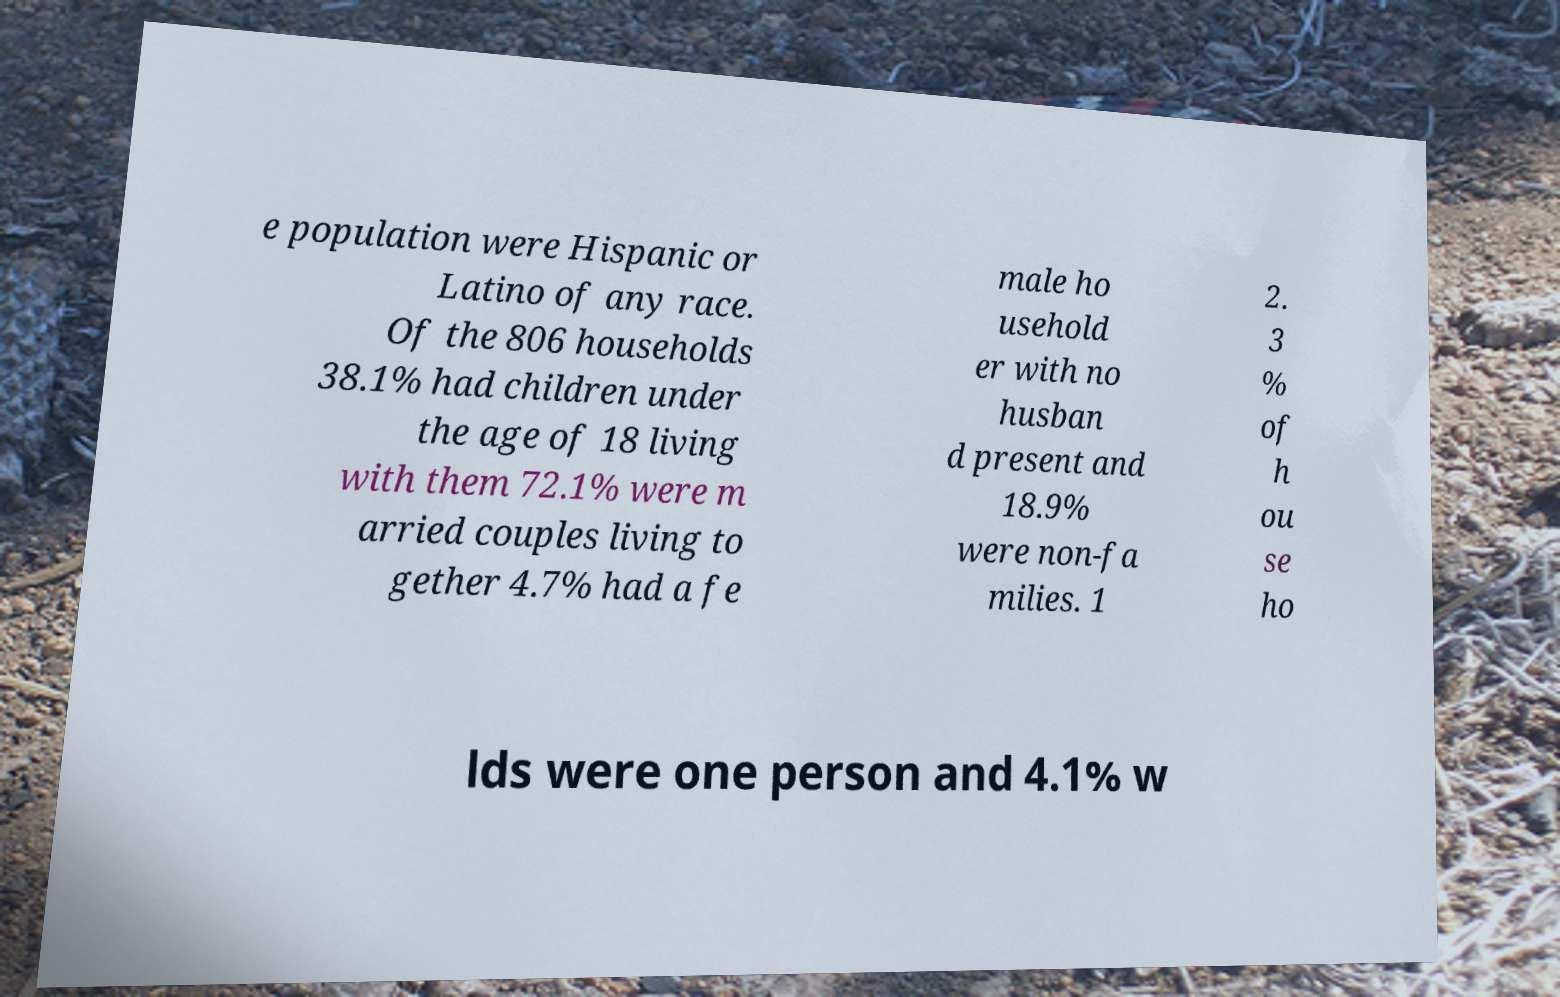Could you assist in decoding the text presented in this image and type it out clearly? e population were Hispanic or Latino of any race. Of the 806 households 38.1% had children under the age of 18 living with them 72.1% were m arried couples living to gether 4.7% had a fe male ho usehold er with no husban d present and 18.9% were non-fa milies. 1 2. 3 % of h ou se ho lds were one person and 4.1% w 